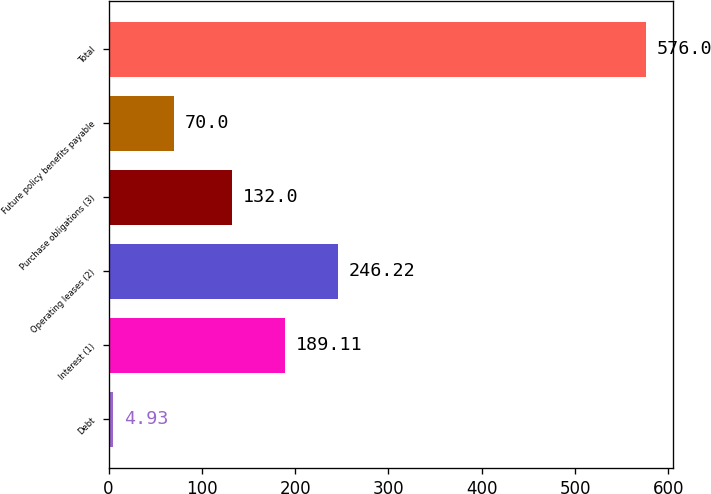<chart> <loc_0><loc_0><loc_500><loc_500><bar_chart><fcel>Debt<fcel>Interest (1)<fcel>Operating leases (2)<fcel>Purchase obligations (3)<fcel>Future policy benefits payable<fcel>Total<nl><fcel>4.93<fcel>189.11<fcel>246.22<fcel>132<fcel>70<fcel>576<nl></chart> 